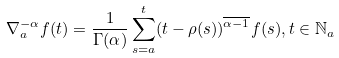<formula> <loc_0><loc_0><loc_500><loc_500>\nabla _ { a } ^ { - \alpha } f ( t ) = \frac { 1 } { \Gamma ( \alpha ) } \sum _ { s = a } ^ { t } ( t - \rho ( s ) ) ^ { \overline { \alpha - 1 } } f ( s ) , t \in \mathbb { N } _ { a }</formula> 